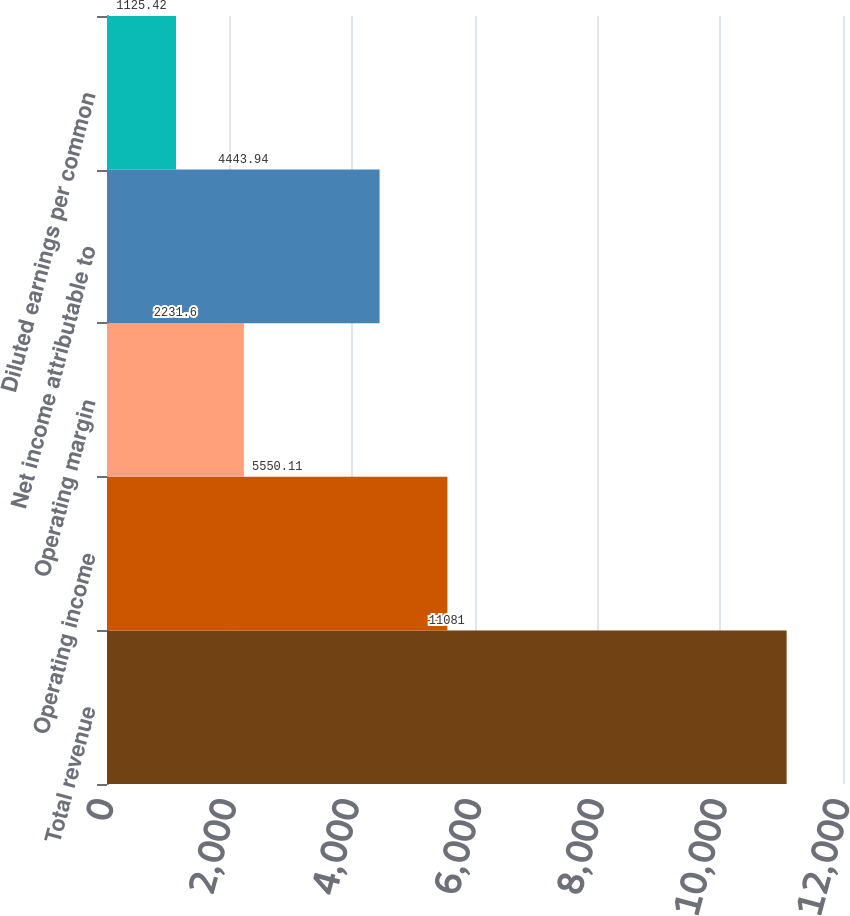Convert chart. <chart><loc_0><loc_0><loc_500><loc_500><bar_chart><fcel>Total revenue<fcel>Operating income<fcel>Operating margin<fcel>Net income attributable to<fcel>Diluted earnings per common<nl><fcel>11081<fcel>5550.11<fcel>2231.6<fcel>4443.94<fcel>1125.42<nl></chart> 